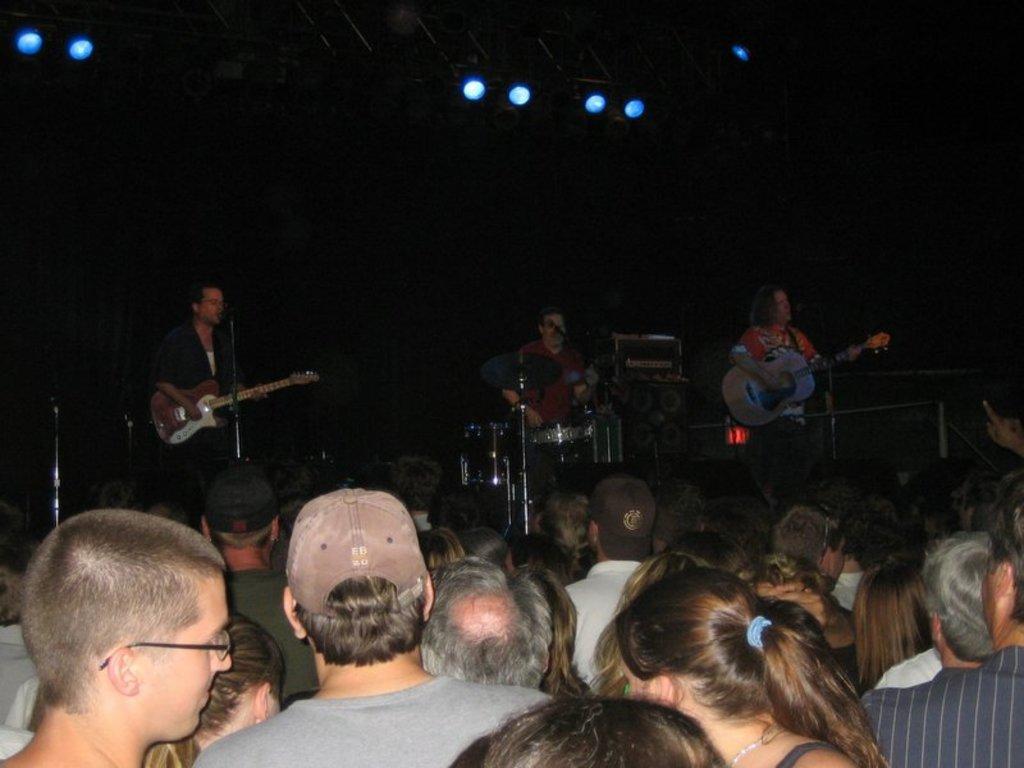In one or two sentences, can you explain what this image depicts? In this image i can see group of people and in the background i can see persons holding musical instruments and few lights. 